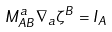Convert formula to latex. <formula><loc_0><loc_0><loc_500><loc_500>M ^ { a } _ { A B } \nabla _ { a } \zeta ^ { B } = I _ { A }</formula> 